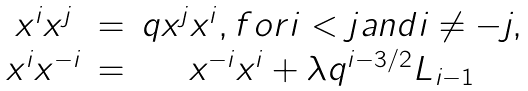<formula> <loc_0><loc_0><loc_500><loc_500>\begin{array} { c c c } x ^ { i } x ^ { j } & = & q x ^ { j } x ^ { i } , f o r i < j a n d i \not = - j , \\ x ^ { i } x ^ { - i } & = & x ^ { - i } x ^ { i } + \lambda q ^ { i - 3 / 2 } L _ { i - 1 } \end{array}</formula> 